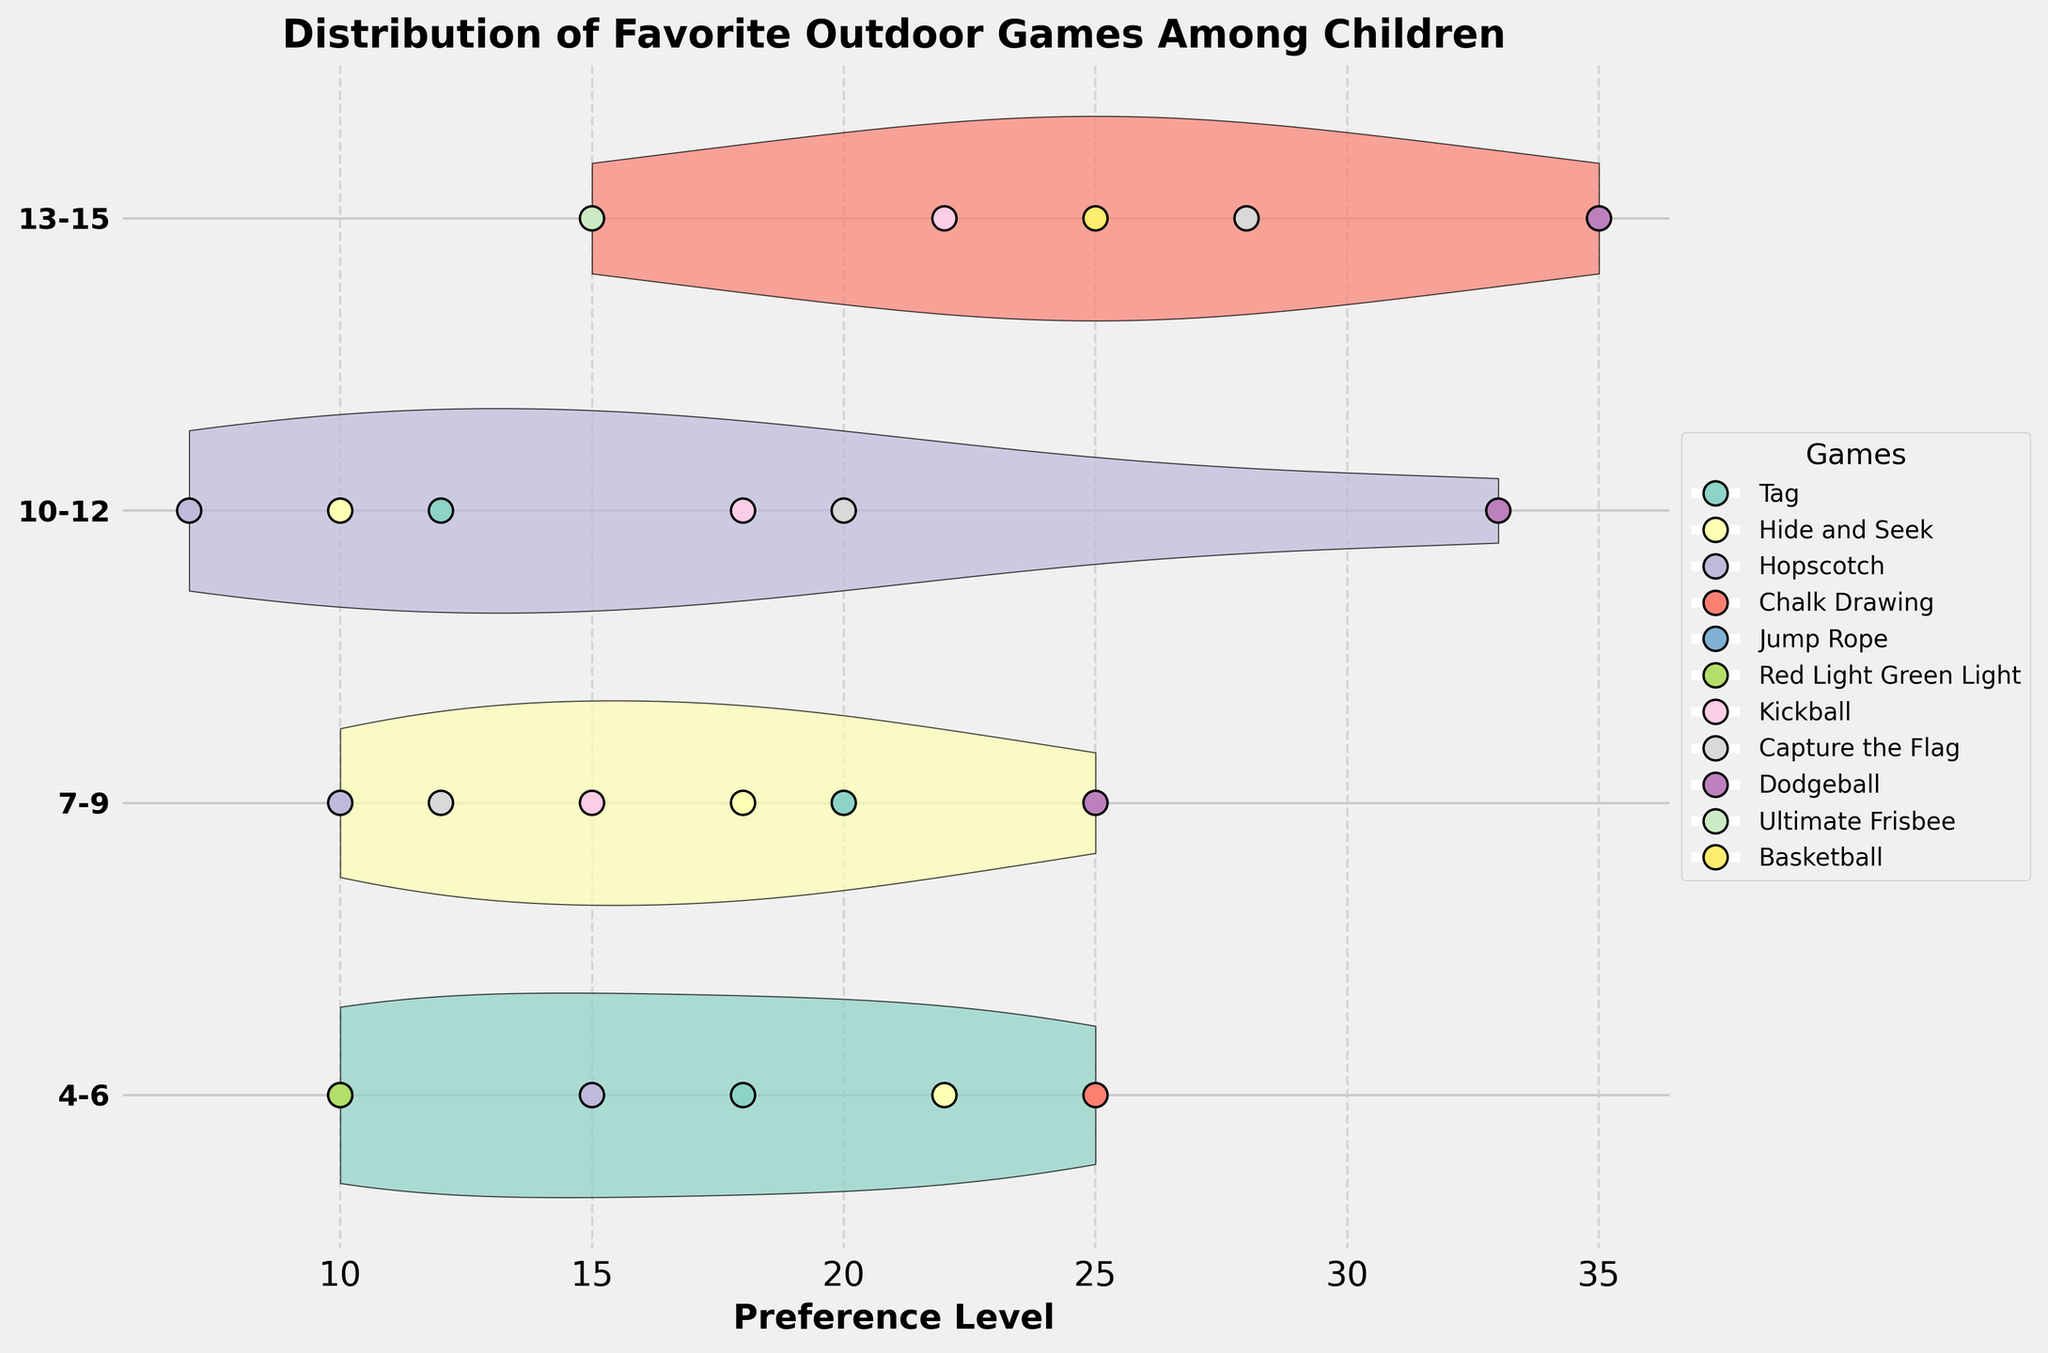What is the title of the chart? The title is displayed at the top of the figure and provides the subject of the visualization.
Answer: Distribution of Favorite Outdoor Games Among Children How many age groups are represented in the chart? The y-axis of the figure lists the age groups that are being compared.
Answer: Four Which age group has the highest preference level for Dodgeball? Look along the distributions for each age group and identify which distribution for Dodgeball extends the furthest on the x-axis.
Answer: 13-15 What is the range of preference levels for Hide and Seek in the 4-6 age group? Examine the horizontal spread of the violin plot for Hide and Seek in the 4-6 age group.
Answer: 0 to 22 Compare the average preference level of Kickball between the 10-12 and 13-15 age groups. Calculate the average preference level by observing the central tendency of the distributions for Kickball in both age groups and comparing them.
Answer: 10-12: 18, 13-15: 22 Which game has the most varied preference levels among the 10-12 age group? Look for the widest violin plot in the 10-12 age group to determine which game shows the most variation.
Answer: Dodgeball Are there more games represented in the 4-6 age group or the 13-15 age group? Count the number of distinct games listed within each age group's data points along the y-axis.
Answer: 4-6 age group How does the preference for Tag change from the 7-9 age group to the 10-12 age group? Compare the position of the Tag preference levels in the 7-9 age group with those in the 10-12 age group along the x-axis.
Answer: Decreases Which age group shows a higher preference for Capture the Flag, 7-9 or 10-12? Compare the positions of the distributions for Capture the Flag in the 7-9 and 10-12 age groups.
Answer: 10-12 What can be said about the preference trends for the game Hopscotch as age increases? Observe and line up the horizontal positions of Hopscotch across each age group to identify any trends.
Answer: Decreases 